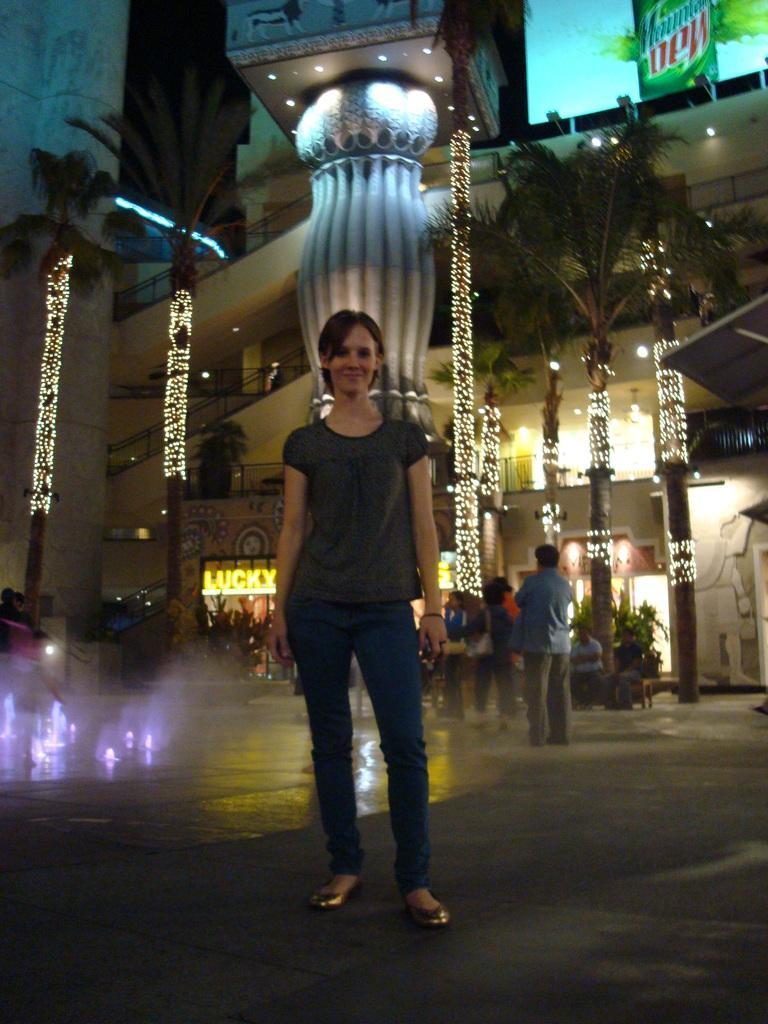In one or two sentences, can you explain what this image depicts? This is an image clicked in the dark. Here I can see a woman standing, smiling and giving pose for the picture. In the background there are some people. In the background there is a building and I can see few poles. 